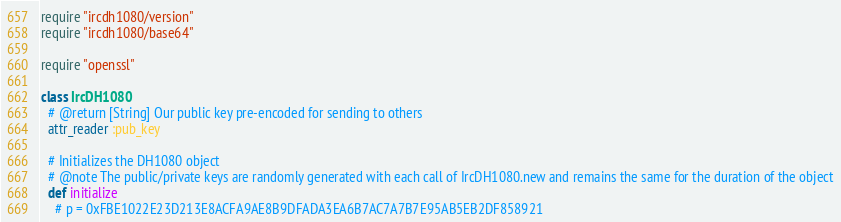Convert code to text. <code><loc_0><loc_0><loc_500><loc_500><_Ruby_>require "ircdh1080/version"
require "ircdh1080/base64"

require "openssl"

class IrcDH1080
  # @return [String] Our public key pre-encoded for sending to others
  attr_reader :pub_key

  # Initializes the DH1080 object
  # @note The public/private keys are randomly generated with each call of IrcDH1080.new and remains the same for the duration of the object
  def initialize
    # p = 0xFBE1022E23D213E8ACFA9AE8B9DFADA3EA6B7AC7A7B7E95AB5EB2DF858921</code> 